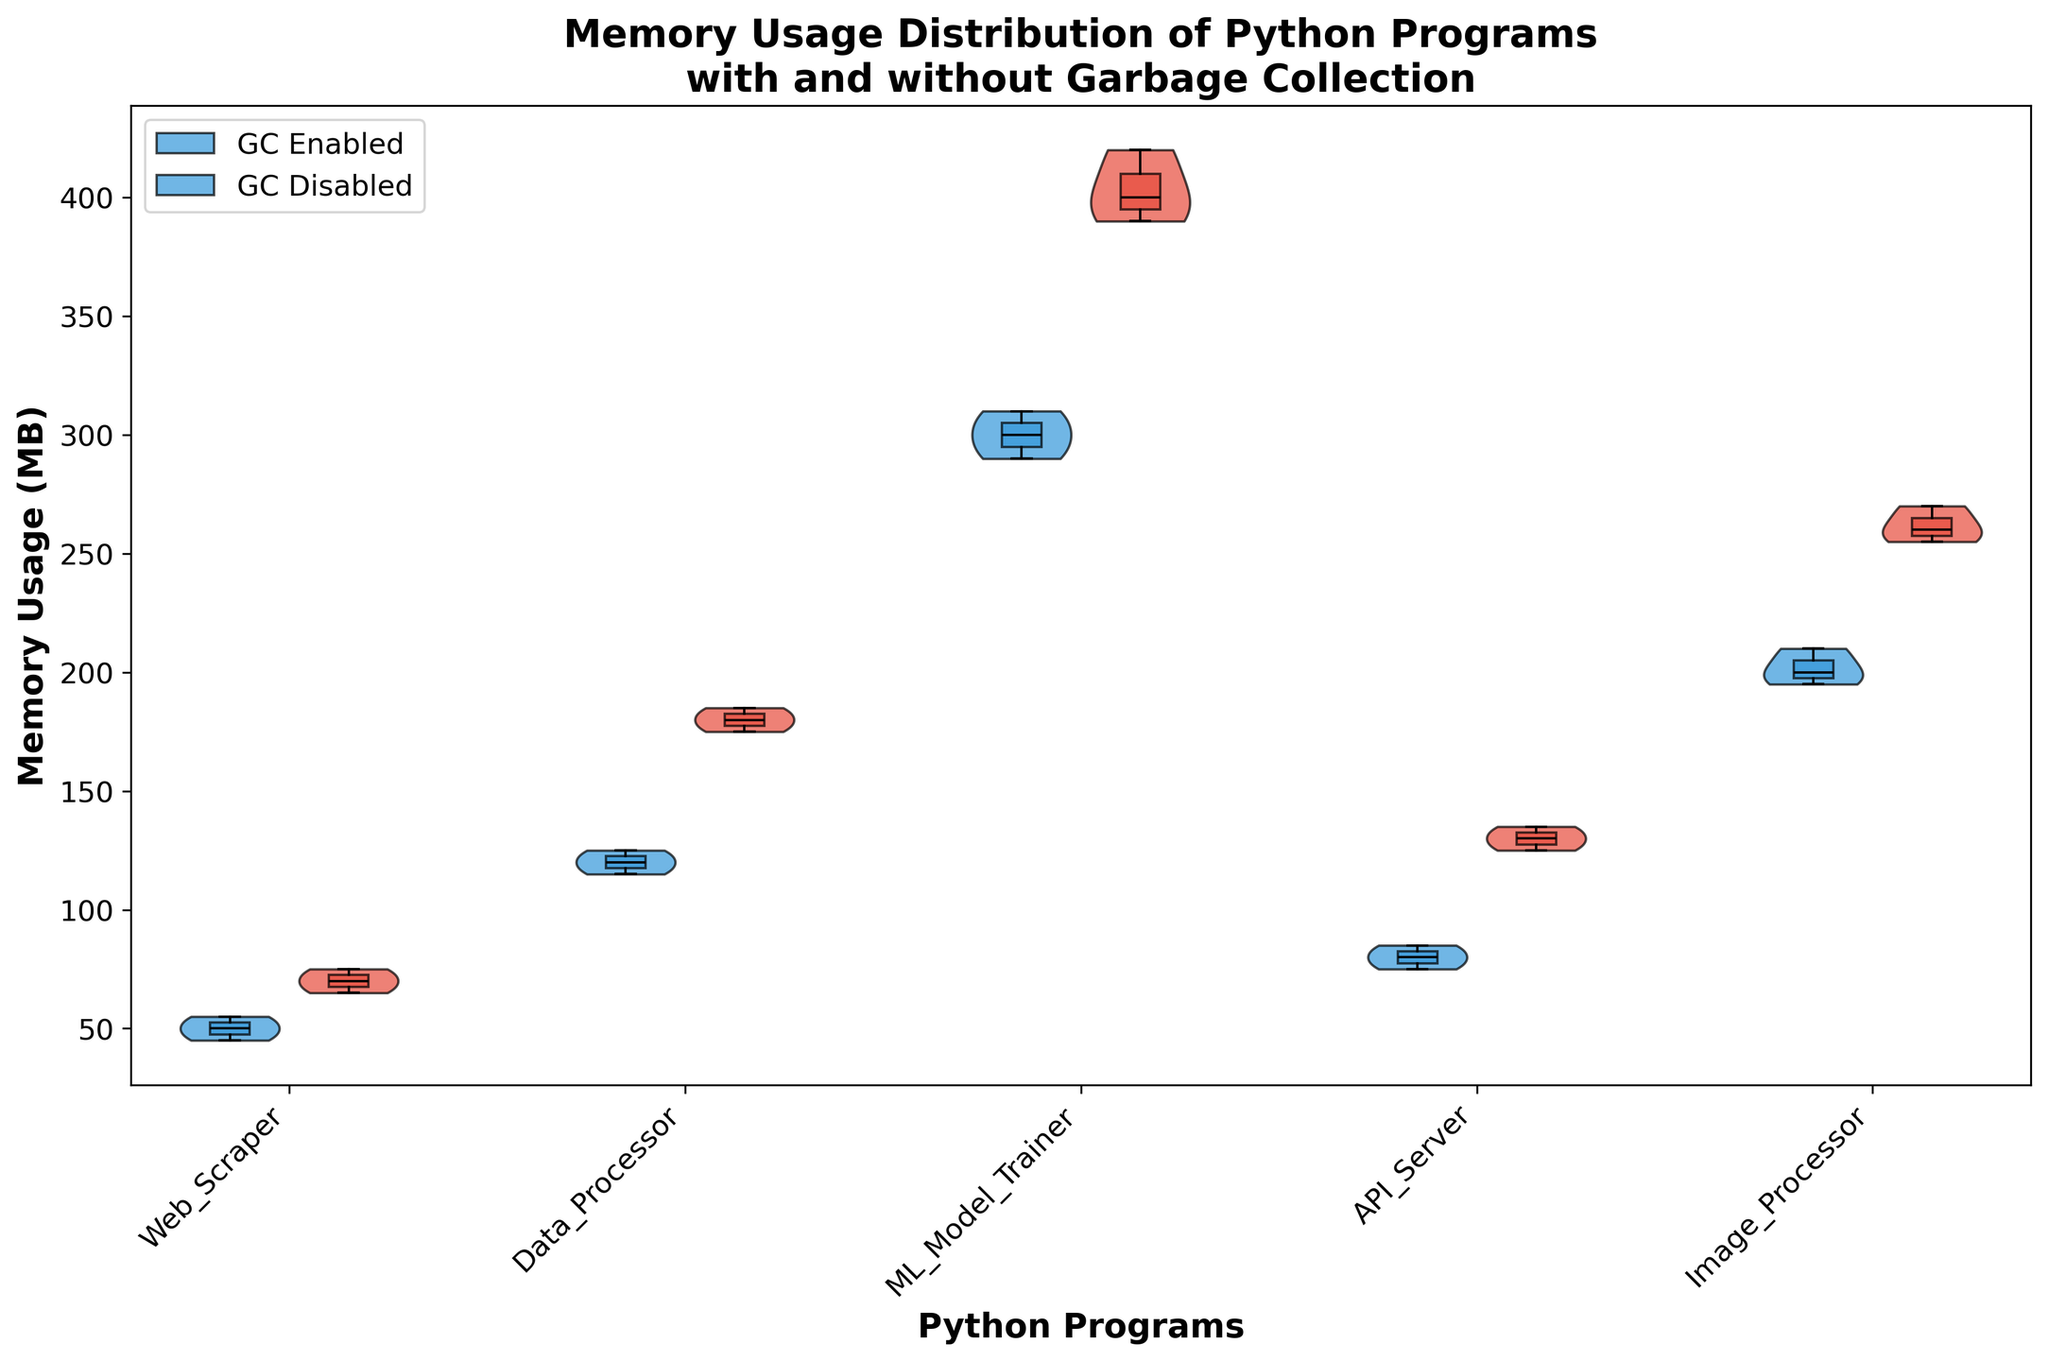What is the title of the figure? The title of the figure is typically found at the top of the chart and it describes the main topic or focus of the visual. In this case, the title is "Memory Usage Distribution of Python Programs\nwith and without Garbage Collection".
Answer: Memory Usage Distribution of Python Programs with and without Garbage Collection Which axis represents the memory usage? The y-axis is typically used to represent numerical values that vary, which in this case is the memory usage in MB. The label on the y-axis confirms this as it reads "Memory Usage (MB)".
Answer: y-axis How are the Python programs distinguished in the figure? The Python programs are labeled on the x-axis, each associated with a position along this axis. The programs listed are Web_Scraper, Data_Processor, ML_Model_Trainer, API_Server, and Image_Processor.
Answer: By the labels on the x-axis What colors represent the garbage collection states, and what do they indicate? The color blue represents garbage collection enabled, while the color red represents garbage collection disabled. This information helps distinguish between the two states within each program's memory usage distribution.
Answer: Blue for enabled, red for disabled What's the difference between the median memory usage of the ML_Model_Trainer with garbage collection enabled and disabled? The median is shown by the horizontal line inside the box of the box plot. For ML_Model_Trainer, the median with garbage collection enabled is around 300 MB, and without it is around 400 MB. The difference is 400 - 300 = 100 MB.
Answer: 100 MB Which program shows the highest memory usage with garbage collection enabled? The highest memory usage can be identified by examining the upper most points in the blue violins. ML_Model_Trainer has the highest usage as its top value reaches around 310 MB.
Answer: ML_Model_Trainer Describe the shape of the memory usage distribution for API_Server with garbage collection disabled. The shape of a violin plot represents the distribution of data points. For API_Server with garbage collection disabled, the red violin plot is wider in the middle around 130 MB, indicating a concentration of data points around this value, and tapering off at both ends.
Answer: Wide middle, taper at ends Are there any noticeable differences in the memory usage distributions of Web_Scraper when garbage collection is enabled versus disabled? By comparing the blue and red violin plots for Web_Scraper, we see that with garbage collection enabled the usage is tight and centered around 50 MB. Without garbage collection, the usage spreads wider and is centered around 70 MB, indicating higher and more variable memory usage.
Answer: Yes, higher and more variable without GC Which program exhibits the largest variance in memory usage when garbage collection is disabled? Variance can be inferred by the width and spread of the violins and box plots. The widest and most spread red violin plot is for ML_Model_Trainer, indicating it has the largest variance in memory usage.
Answer: ML_Model_Trainer 